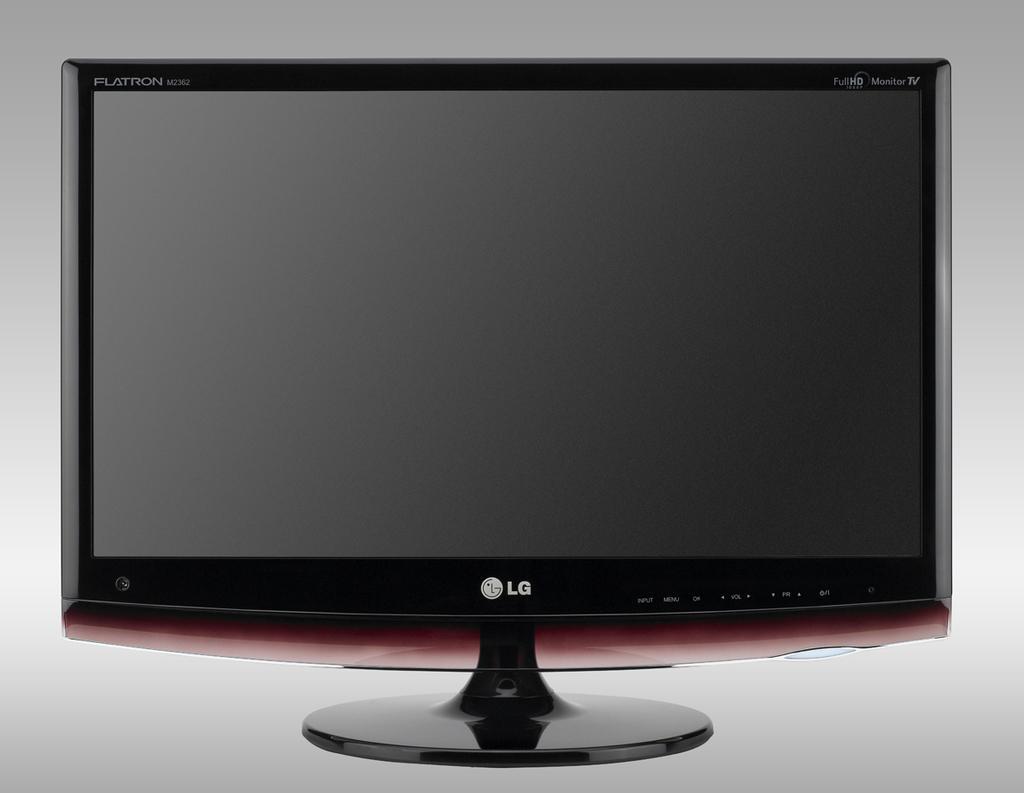In one or two sentences, can you explain what this image depicts? In this image we can see a television, on the top left and right corner of the television some text is written, at the bottom of the screen there is a logo and a text. 